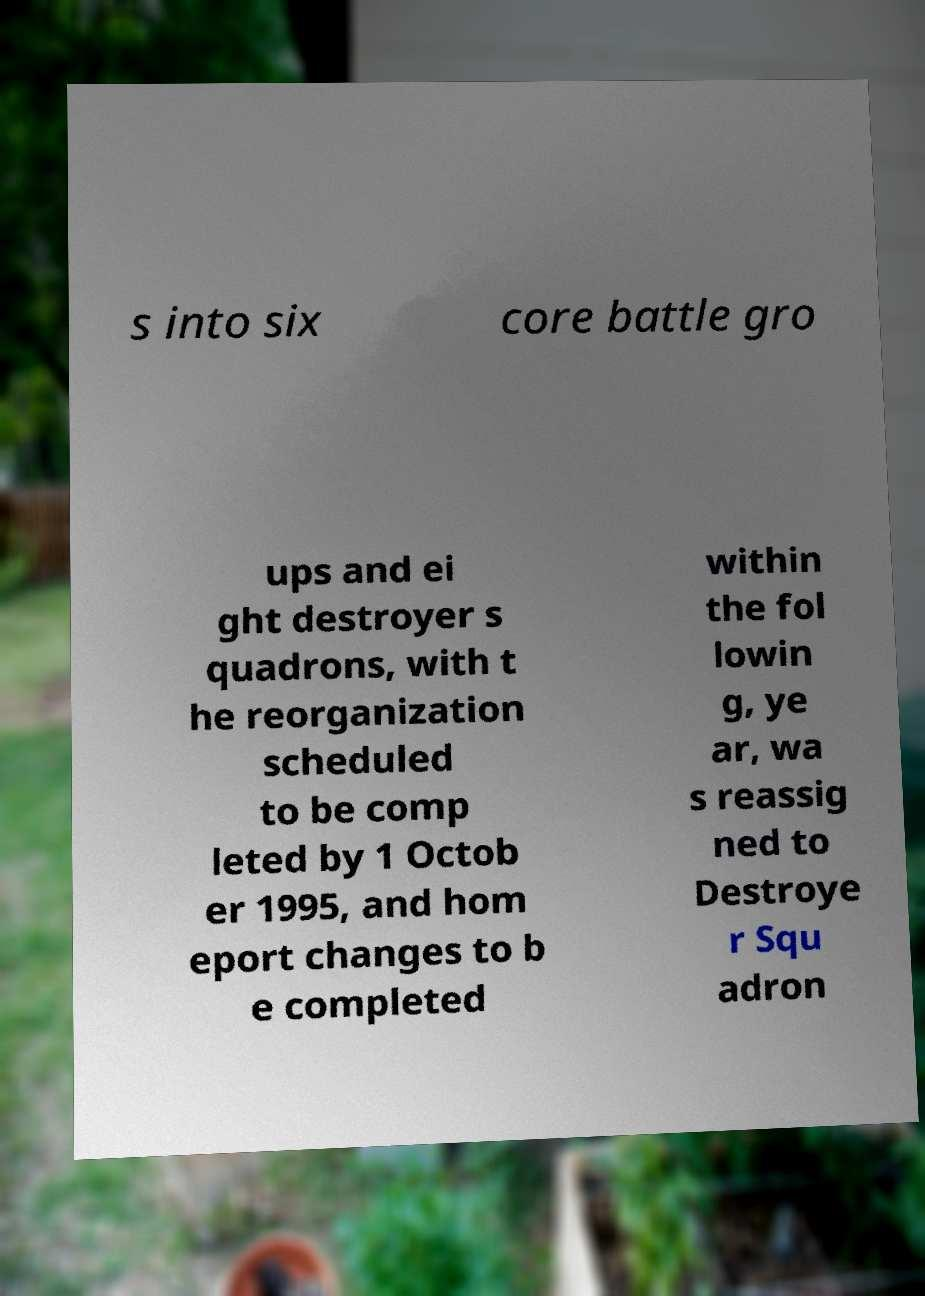Can you read and provide the text displayed in the image?This photo seems to have some interesting text. Can you extract and type it out for me? s into six core battle gro ups and ei ght destroyer s quadrons, with t he reorganization scheduled to be comp leted by 1 Octob er 1995, and hom eport changes to b e completed within the fol lowin g, ye ar, wa s reassig ned to Destroye r Squ adron 